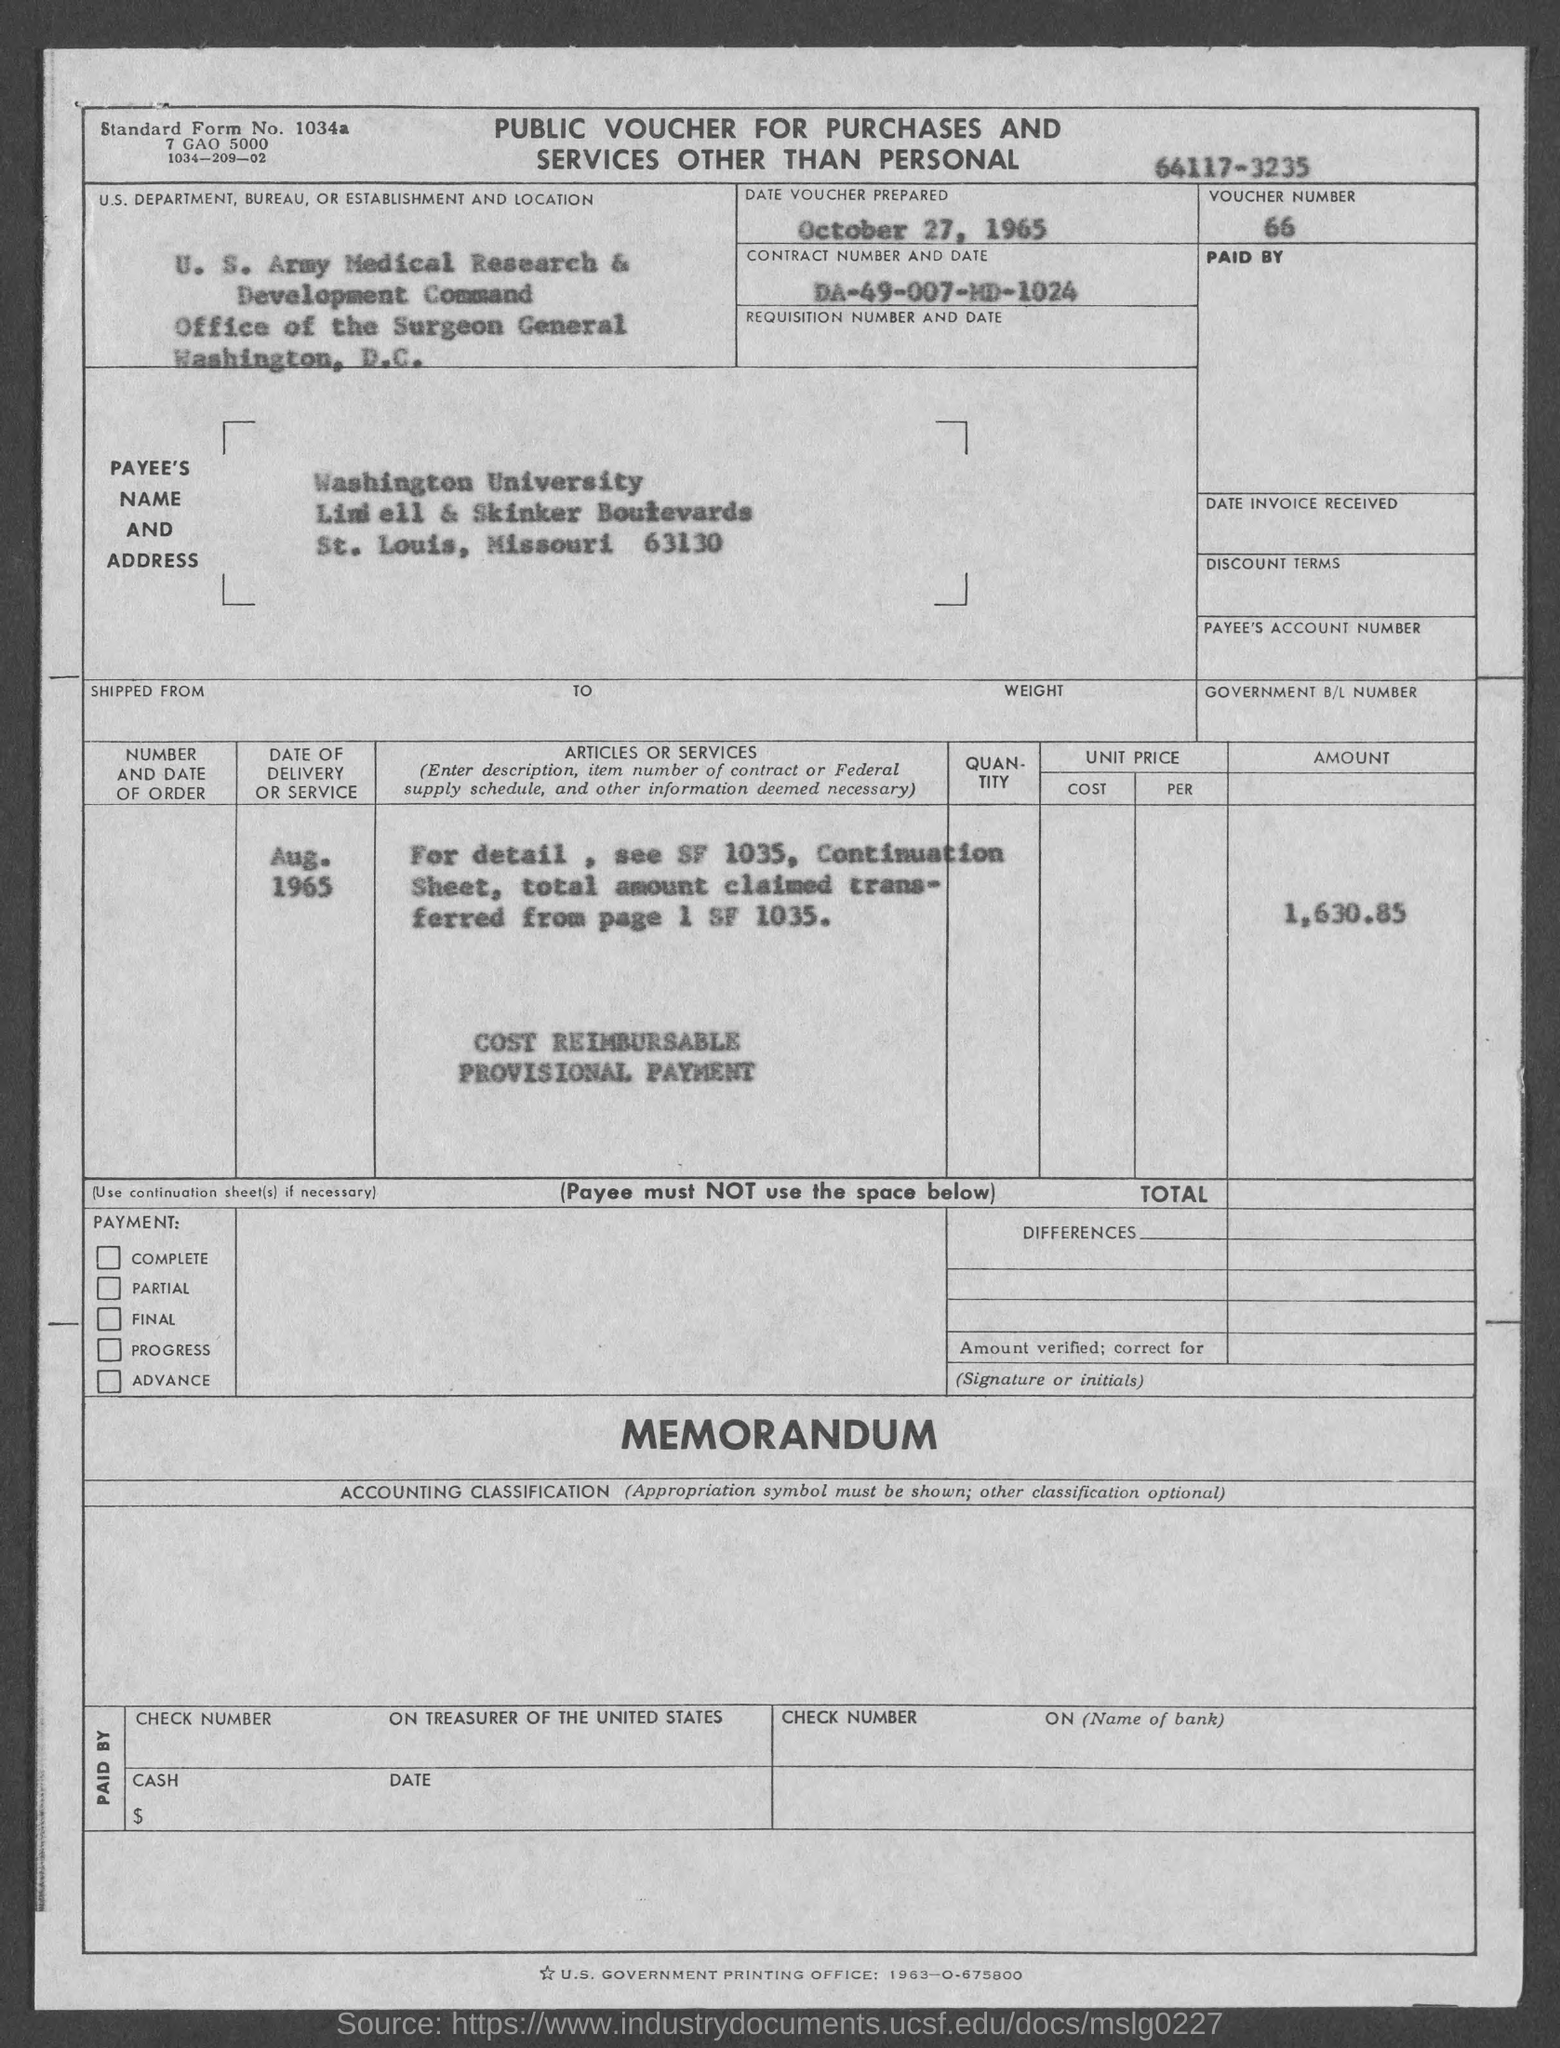List a handful of essential elements in this visual. The date of the voucher was prepared on October 27, 1965. The voucher number is 66... The payee's name is Washington University. 